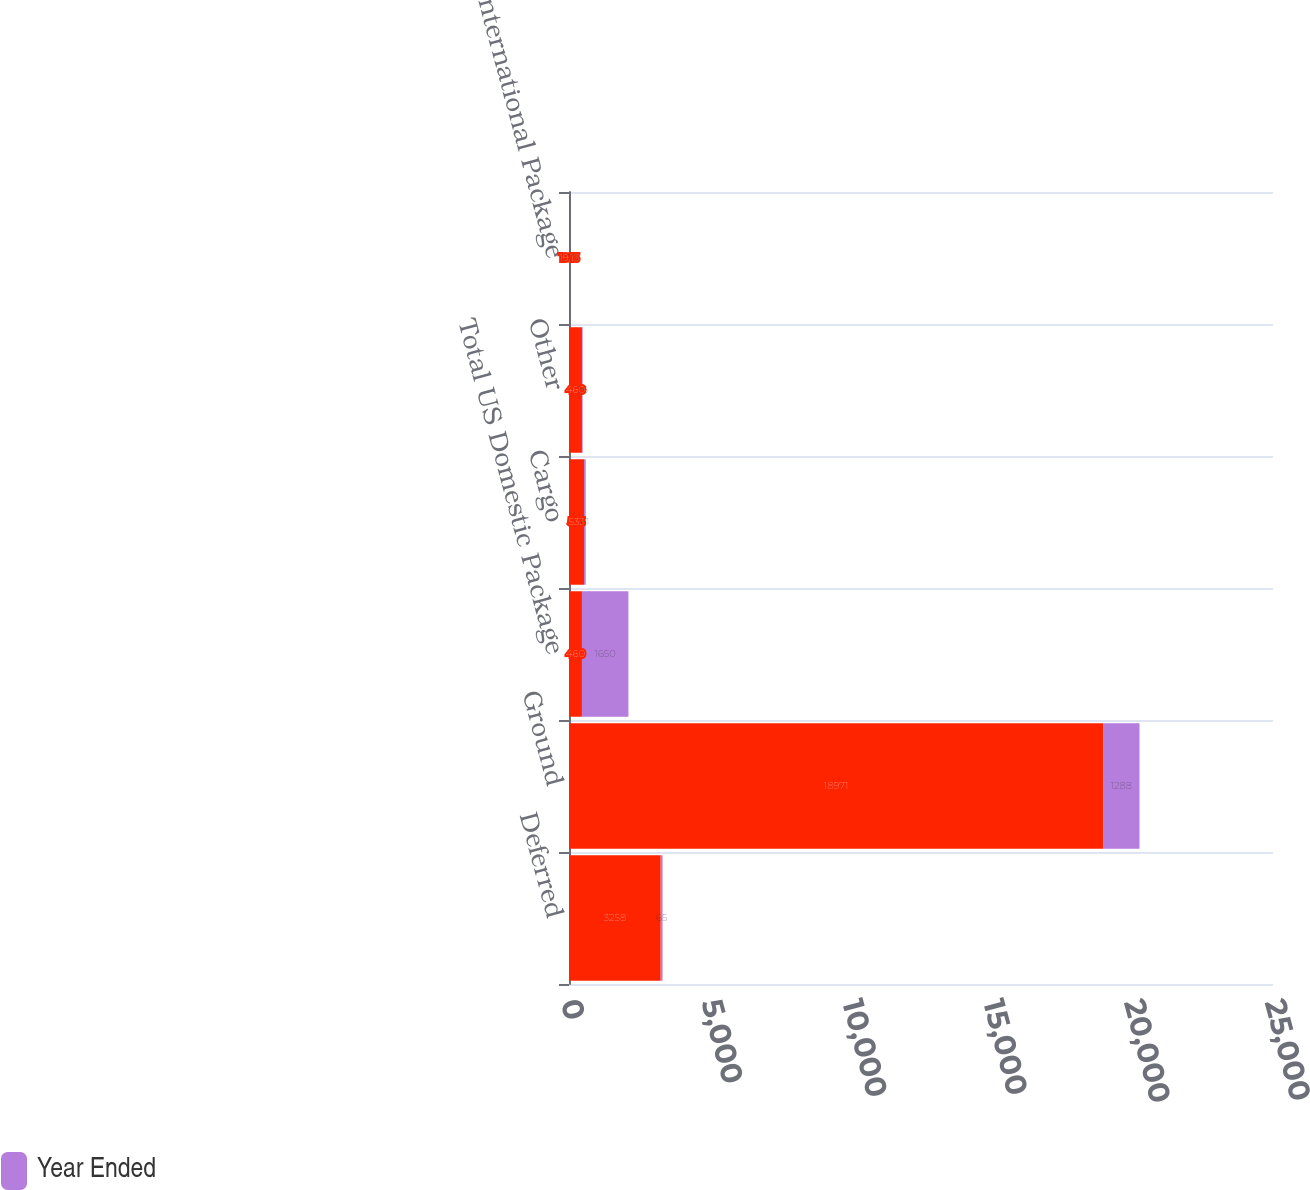<chart> <loc_0><loc_0><loc_500><loc_500><stacked_bar_chart><ecel><fcel>Deferred<fcel>Ground<fcel>Total US Domestic Package<fcel>Cargo<fcel>Other<fcel>Total International Package<nl><fcel>nan<fcel>3258<fcel>18971<fcel>460<fcel>533<fcel>460<fcel>19.13<nl><fcel>Year Ended<fcel>65<fcel>1288<fcel>1650<fcel>61<fcel>26<fcel>0.73<nl></chart> 